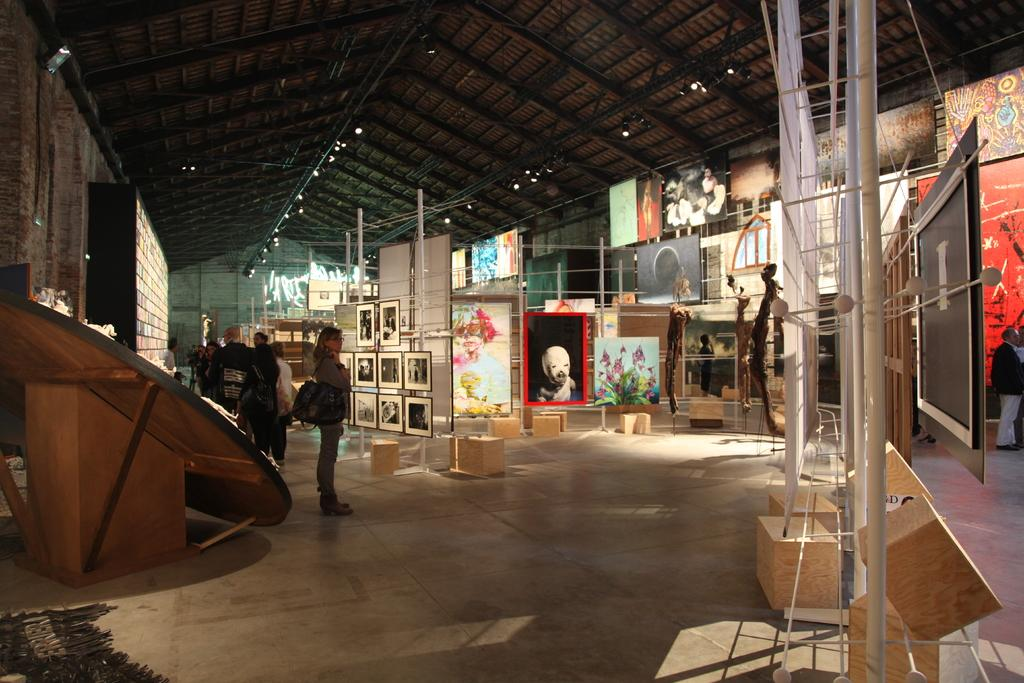What type of establishment is depicted in the image? There is an art gallery in the image. What are the people in the image doing? People are standing on the floor in the art gallery. What can be seen on the walls of the art gallery? There are photo frames on the wall in the art gallery. What type of sand can be seen on the floor of the art gallery? There is no sand visible on the floor of the art gallery in the image. What relation do the people in the image have to each other? The image does not provide information about the relationships between the people in the art gallery. 